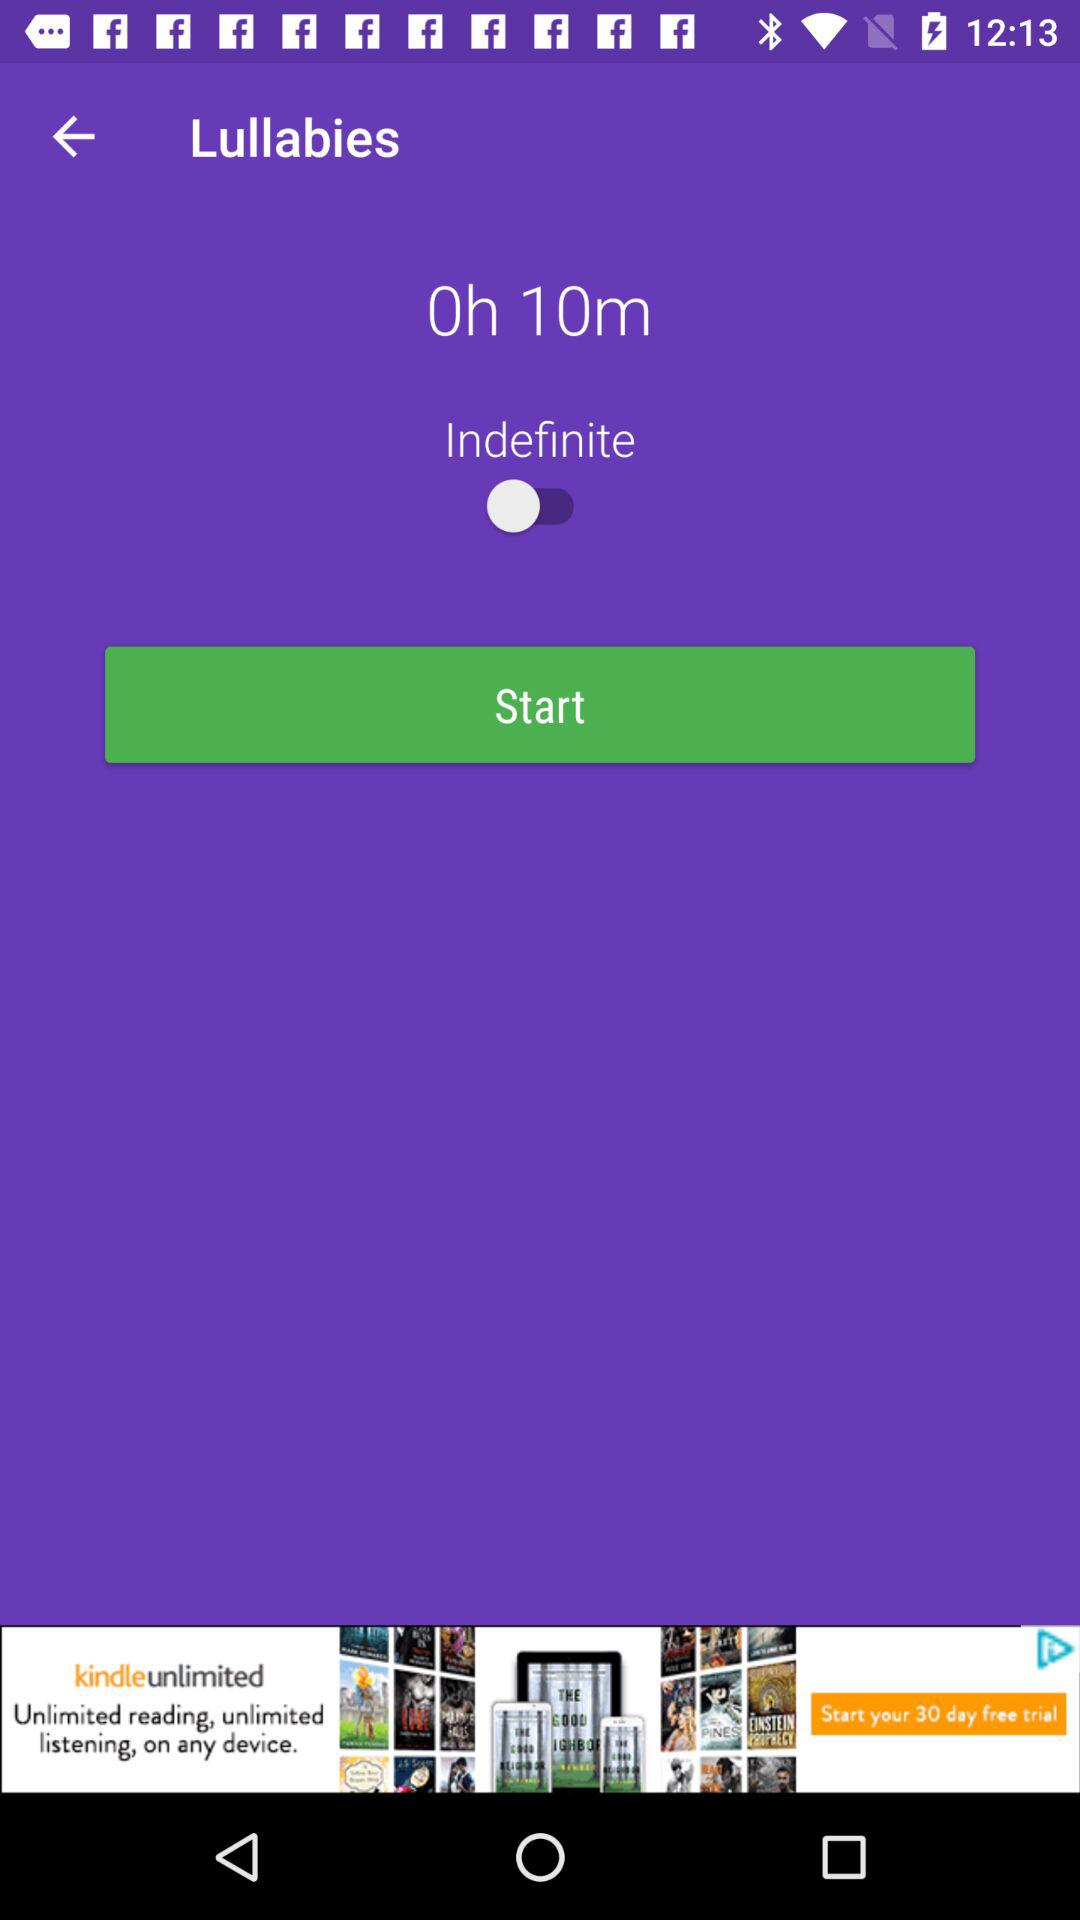What is the given duration? The given duration is 10 minutes. 